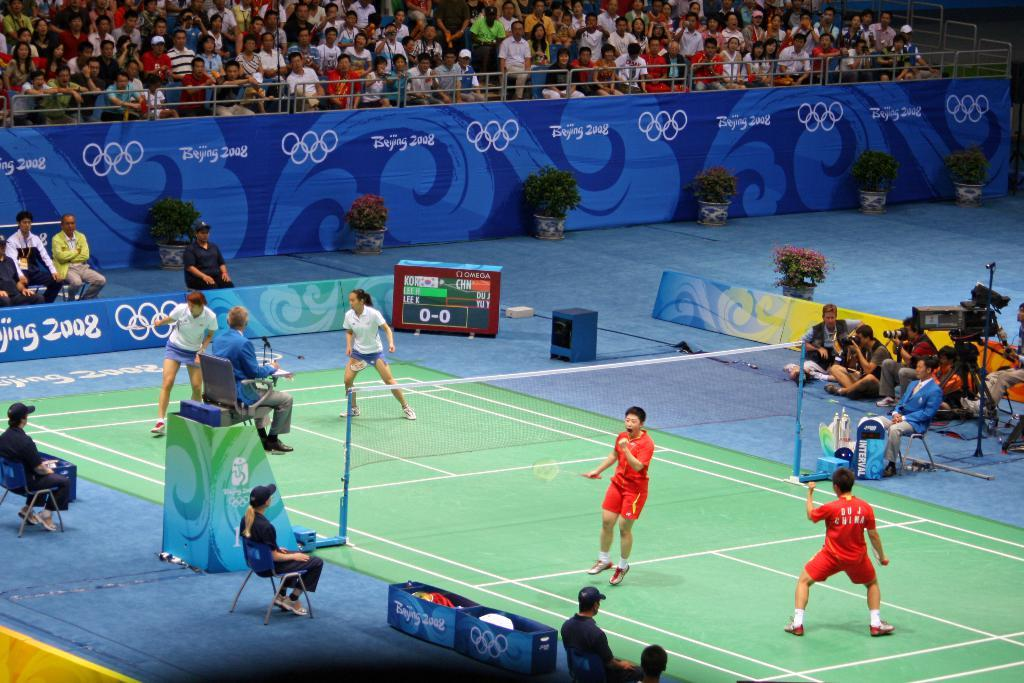<image>
Summarize the visual content of the image. Inside match with a large blue banner with Bejing 2008 in white lettering. 